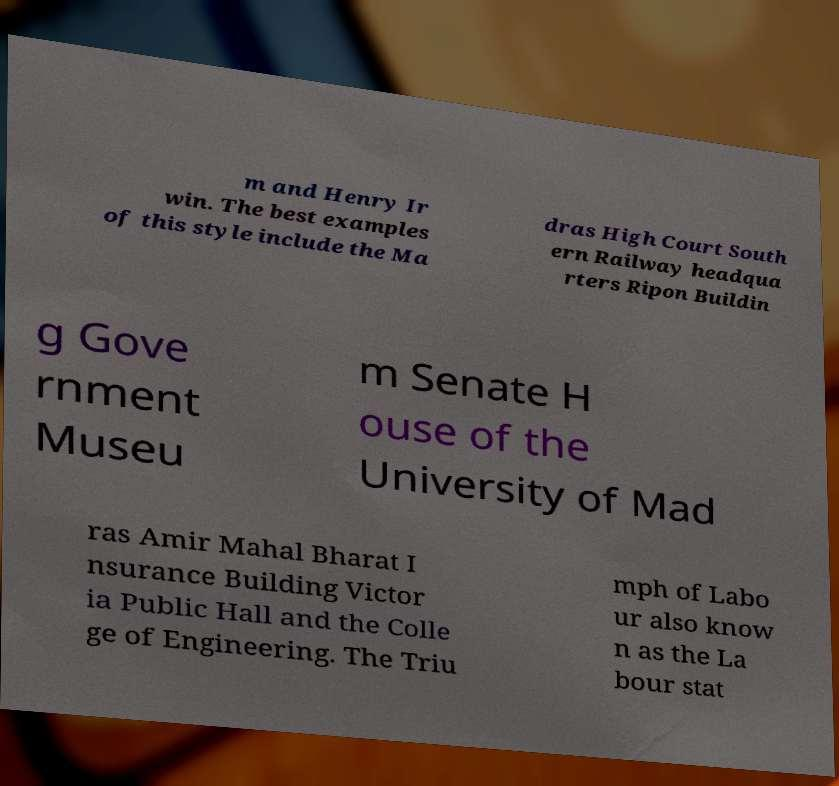I need the written content from this picture converted into text. Can you do that? m and Henry Ir win. The best examples of this style include the Ma dras High Court South ern Railway headqua rters Ripon Buildin g Gove rnment Museu m Senate H ouse of the University of Mad ras Amir Mahal Bharat I nsurance Building Victor ia Public Hall and the Colle ge of Engineering. The Triu mph of Labo ur also know n as the La bour stat 